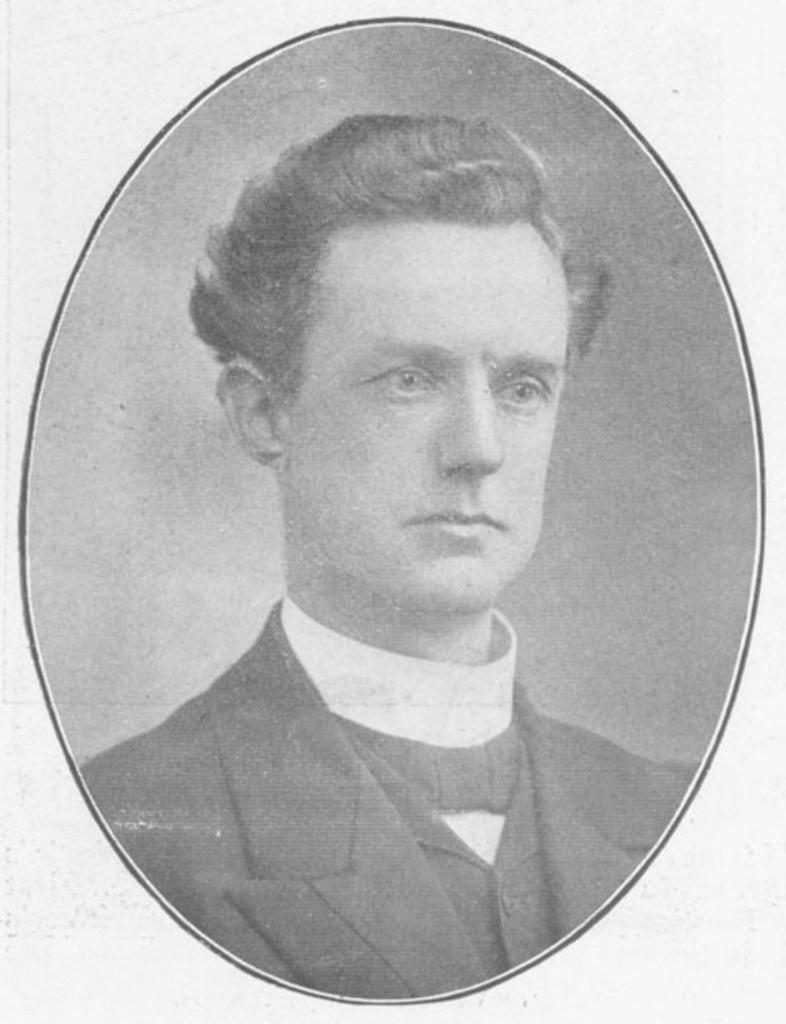What is the color scheme of the picture? The picture is black and white. Who is in the picture? There is a man in the picture. What is the man wearing? The man is wearing a blazer. What type of vessel is the man using to navigate the street in the image? There is no vessel or street present in the image; it is a black and white picture of a man wearing a blazer. 